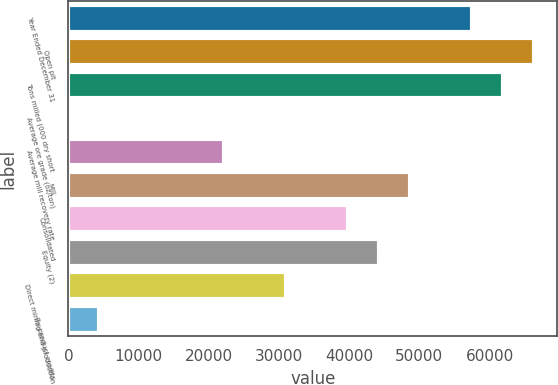<chart> <loc_0><loc_0><loc_500><loc_500><bar_chart><fcel>Year Ended December 31<fcel>Open pit<fcel>Tons milled (000 dry short<fcel>Average ore grade (oz/ton)<fcel>Average mill recovery rate<fcel>Mill<fcel>Consolidated<fcel>Equity (2)<fcel>Direct mining and production<fcel>By-product credits<nl><fcel>57505.4<fcel>66352.4<fcel>61928.9<fcel>0.06<fcel>22117.5<fcel>48658.4<fcel>39811.5<fcel>44235<fcel>30964.5<fcel>4423.55<nl></chart> 